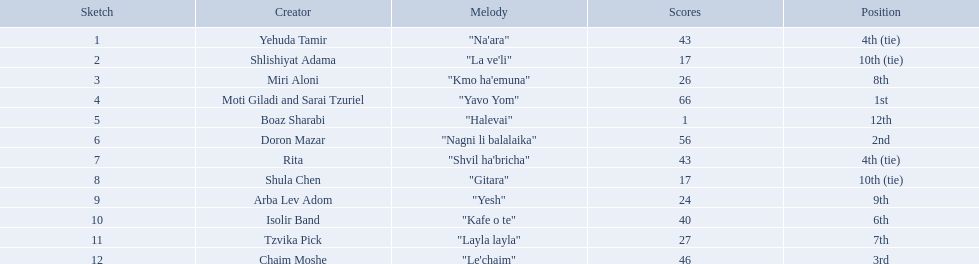Who were all the artists at the contest? Yehuda Tamir, Shlishiyat Adama, Miri Aloni, Moti Giladi and Sarai Tzuriel, Boaz Sharabi, Doron Mazar, Rita, Shula Chen, Arba Lev Adom, Isolir Band, Tzvika Pick, Chaim Moshe. Give me the full table as a dictionary. {'header': ['Sketch', 'Creator', 'Melody', 'Scores', 'Position'], 'rows': [['1', 'Yehuda Tamir', '"Na\'ara"', '43', '4th (tie)'], ['2', 'Shlishiyat Adama', '"La ve\'li"', '17', '10th (tie)'], ['3', 'Miri Aloni', '"Kmo ha\'emuna"', '26', '8th'], ['4', 'Moti Giladi and Sarai Tzuriel', '"Yavo Yom"', '66', '1st'], ['5', 'Boaz Sharabi', '"Halevai"', '1', '12th'], ['6', 'Doron Mazar', '"Nagni li balalaika"', '56', '2nd'], ['7', 'Rita', '"Shvil ha\'bricha"', '43', '4th (tie)'], ['8', 'Shula Chen', '"Gitara"', '17', '10th (tie)'], ['9', 'Arba Lev Adom', '"Yesh"', '24', '9th'], ['10', 'Isolir Band', '"Kafe o te"', '40', '6th'], ['11', 'Tzvika Pick', '"Layla layla"', '27', '7th'], ['12', 'Chaim Moshe', '"Le\'chaim"', '46', '3rd']]} What were their point totals? 43, 17, 26, 66, 1, 56, 43, 17, 24, 40, 27, 46. Of these, which is the least amount of points? 1. Which artists received this point total? Boaz Sharabi. What are the points? 43, 17, 26, 66, 1, 56, 43, 17, 24, 40, 27, 46. What is the least? 1. Which artist has that much Boaz Sharabi. What is the place of the contestant who received only 1 point? 12th. What is the name of the artist listed in the previous question? Boaz Sharabi. 